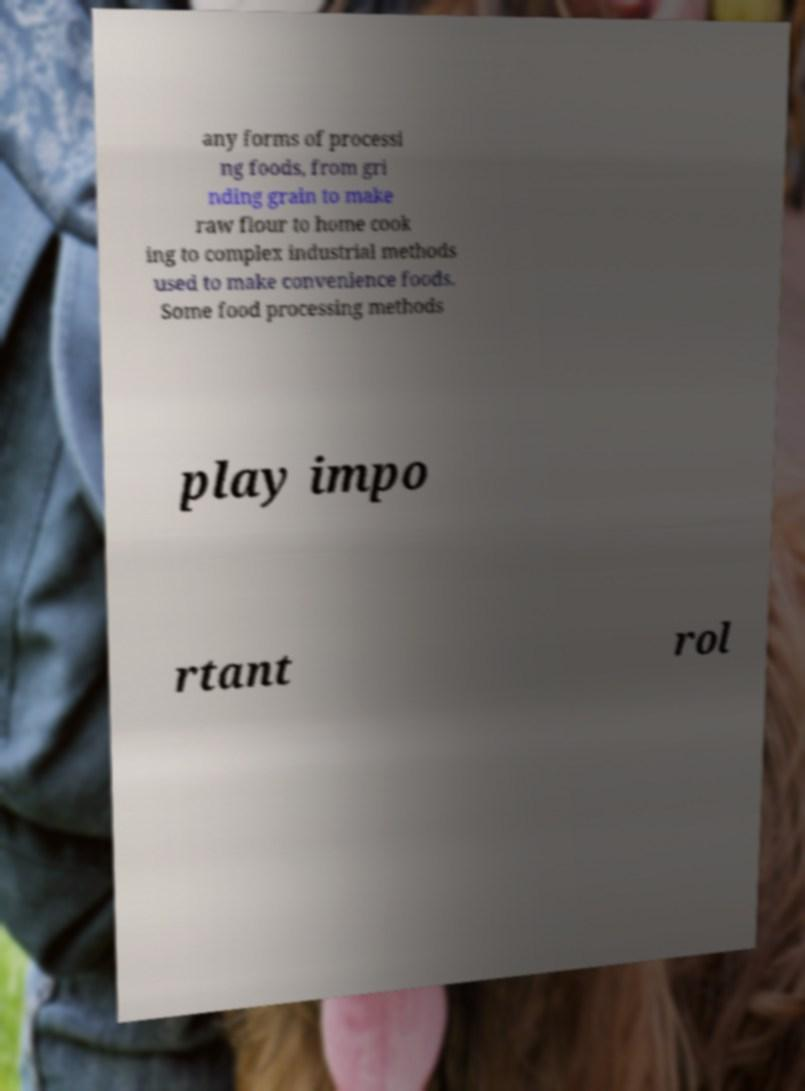Can you read and provide the text displayed in the image?This photo seems to have some interesting text. Can you extract and type it out for me? any forms of processi ng foods, from gri nding grain to make raw flour to home cook ing to complex industrial methods used to make convenience foods. Some food processing methods play impo rtant rol 